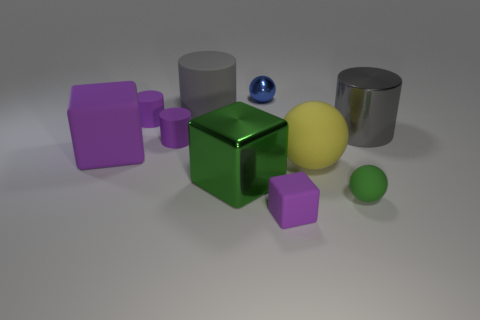Is there a purple rubber cylinder? Indeed, the image displays a purple rubber cylinder among various other geometric shapes, each with a different material appearance. 